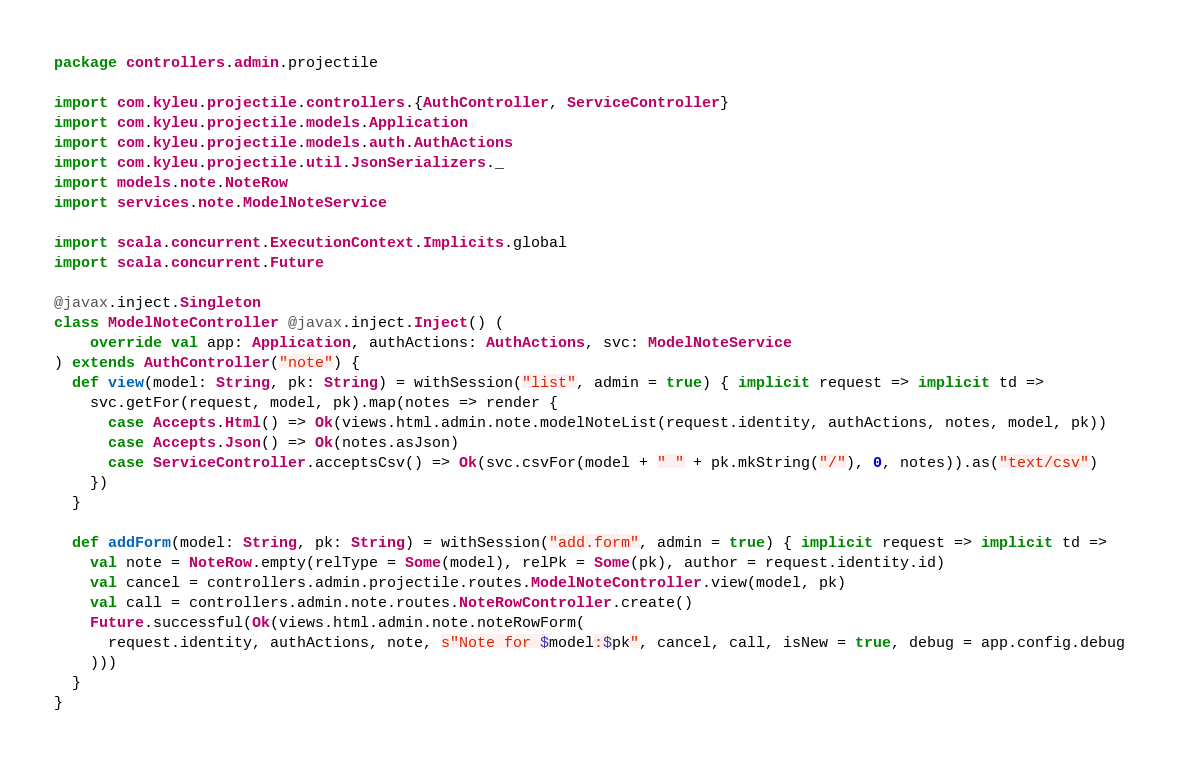<code> <loc_0><loc_0><loc_500><loc_500><_Scala_>package controllers.admin.projectile

import com.kyleu.projectile.controllers.{AuthController, ServiceController}
import com.kyleu.projectile.models.Application
import com.kyleu.projectile.models.auth.AuthActions
import com.kyleu.projectile.util.JsonSerializers._
import models.note.NoteRow
import services.note.ModelNoteService

import scala.concurrent.ExecutionContext.Implicits.global
import scala.concurrent.Future

@javax.inject.Singleton
class ModelNoteController @javax.inject.Inject() (
    override val app: Application, authActions: AuthActions, svc: ModelNoteService
) extends AuthController("note") {
  def view(model: String, pk: String) = withSession("list", admin = true) { implicit request => implicit td =>
    svc.getFor(request, model, pk).map(notes => render {
      case Accepts.Html() => Ok(views.html.admin.note.modelNoteList(request.identity, authActions, notes, model, pk))
      case Accepts.Json() => Ok(notes.asJson)
      case ServiceController.acceptsCsv() => Ok(svc.csvFor(model + " " + pk.mkString("/"), 0, notes)).as("text/csv")
    })
  }

  def addForm(model: String, pk: String) = withSession("add.form", admin = true) { implicit request => implicit td =>
    val note = NoteRow.empty(relType = Some(model), relPk = Some(pk), author = request.identity.id)
    val cancel = controllers.admin.projectile.routes.ModelNoteController.view(model, pk)
    val call = controllers.admin.note.routes.NoteRowController.create()
    Future.successful(Ok(views.html.admin.note.noteRowForm(
      request.identity, authActions, note, s"Note for $model:$pk", cancel, call, isNew = true, debug = app.config.debug
    )))
  }
}
</code> 